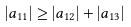Convert formula to latex. <formula><loc_0><loc_0><loc_500><loc_500>| a _ { 1 1 } | \geq | a _ { 1 2 } | + | a _ { 1 3 } |</formula> 